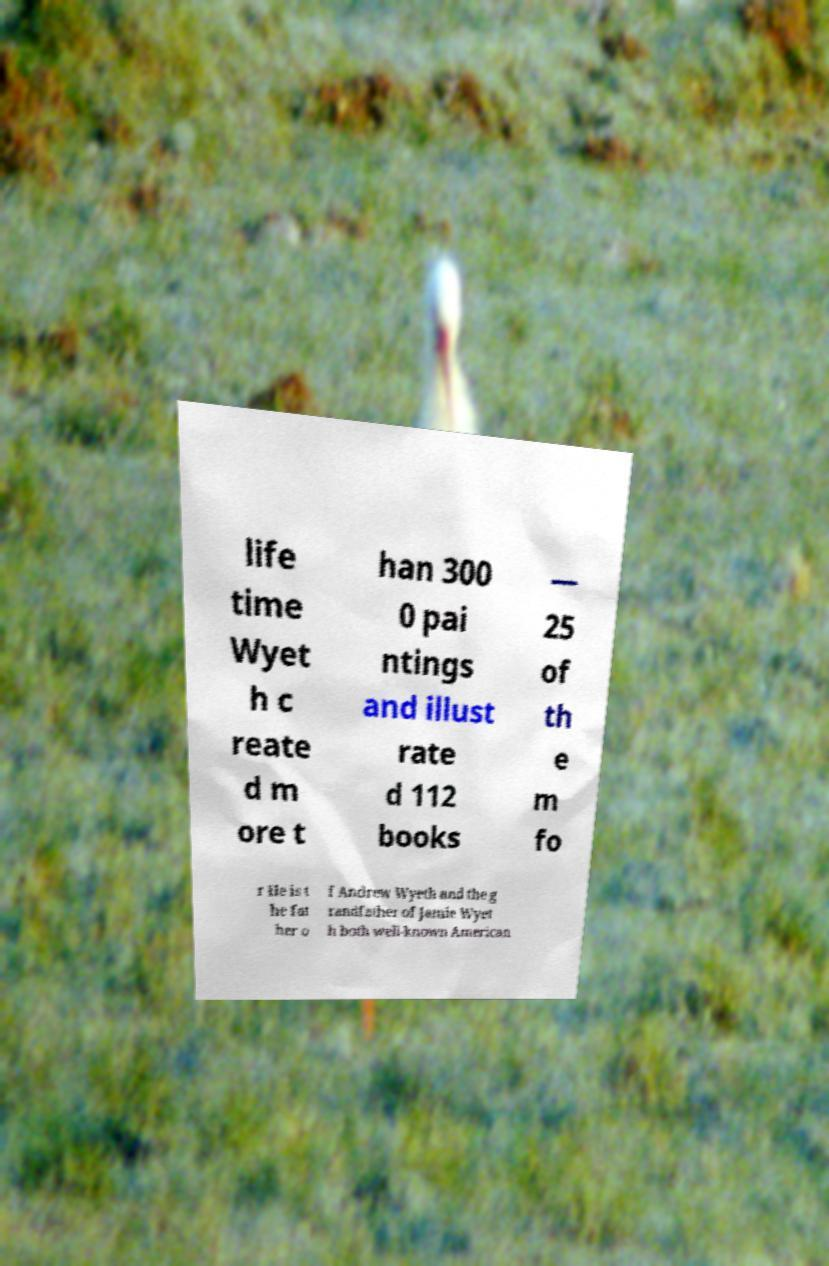What messages or text are displayed in this image? I need them in a readable, typed format. life time Wyet h c reate d m ore t han 300 0 pai ntings and illust rate d 112 books — 25 of th e m fo r He is t he fat her o f Andrew Wyeth and the g randfather of Jamie Wyet h both well-known American 